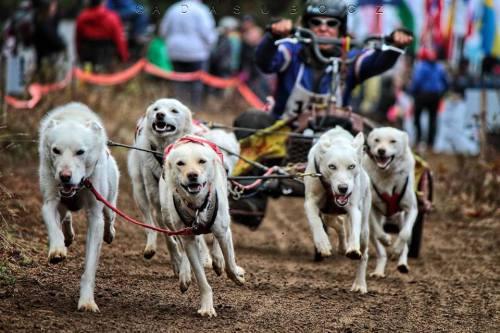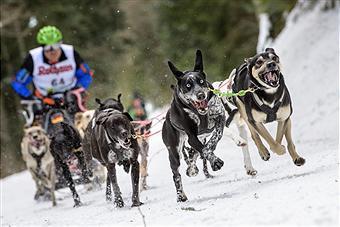The first image is the image on the left, the second image is the image on the right. For the images displayed, is the sentence "The sled rider in the image on the left is wearing a white vest with a number." factually correct? Answer yes or no. Yes. The first image is the image on the left, the second image is the image on the right. Given the left and right images, does the statement "Right image shows a team of dogs moving over snowy ground toward the camera." hold true? Answer yes or no. Yes. 